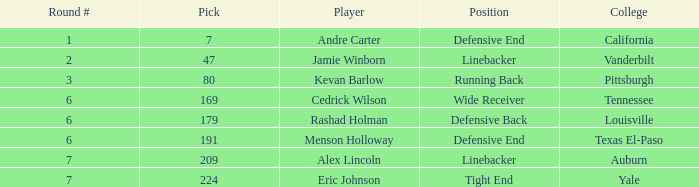Which pick came from Texas El-Paso? 191.0. 